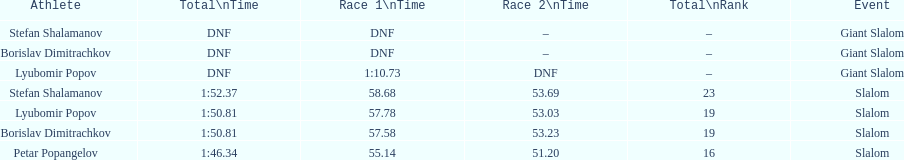Who was last in the slalom overall? Stefan Shalamanov. 